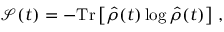Convert formula to latex. <formula><loc_0><loc_0><loc_500><loc_500>\mathcal { S } ( t ) = - T r \left [ \hat { \rho } ( t ) \log \hat { \rho } ( t ) \right ] \, ,</formula> 